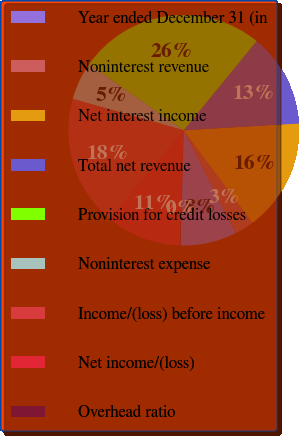Convert chart. <chart><loc_0><loc_0><loc_500><loc_500><pie_chart><fcel>Year ended December 31 (in<fcel>Noninterest revenue<fcel>Net interest income<fcel>Total net revenue<fcel>Provision for credit losses<fcel>Noninterest expense<fcel>Income/(loss) before income<fcel>Net income/(loss)<fcel>Overhead ratio<nl><fcel>7.92%<fcel>2.69%<fcel>15.76%<fcel>13.14%<fcel>26.22%<fcel>5.3%<fcel>18.37%<fcel>10.53%<fcel>0.07%<nl></chart> 